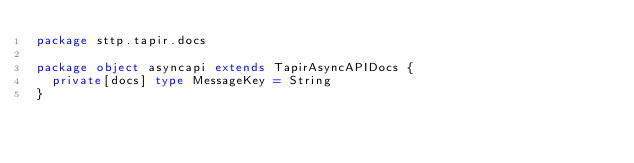Convert code to text. <code><loc_0><loc_0><loc_500><loc_500><_Scala_>package sttp.tapir.docs

package object asyncapi extends TapirAsyncAPIDocs {
  private[docs] type MessageKey = String
}
</code> 